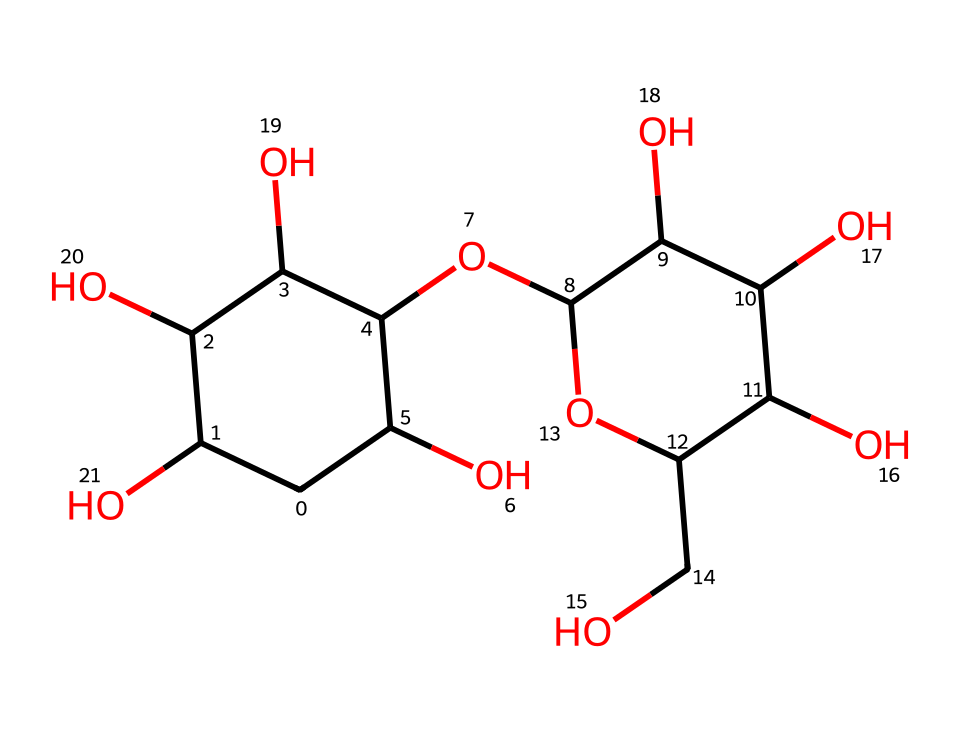What is the base sugar unit in this structure? The chemical structure shows a series of interconnected rings with hydroxyl groups, indicative of polysaccharides. The presence of multiple -OH groups confirms it is composed of sugar units, specifically glucose, which is the base unit of starch.
Answer: glucose How many hydroxyl functional groups are present? By analyzing the structure, we count the -OH groups present. Each -OH count correlates with the branched structure of cornstarch, leading to a total of six hydroxyl groups.
Answer: six What type of fluid is created by cornstarch when mixed with water? The combination of cornstarch and water results in a non-Newtonian fluid known as oobleck, where the mixture exhibits properties of both solid and liquid under different stress conditions.
Answer: non-Newtonian How does the structure affect the viscosity of oobleck? The complex starch structure leads to increased molecular interactions through hydrogen bonding among hydroxyl groups, causing the mixture to become more viscous when under stress. Therefore, it behaves differently than typical fluids.
Answer: increased viscosity What is the primary factor in oobleck’s solid-like behavior under stress? The starch’s structural integrity and the ability to form temporary bonds under stress create resistance to flow, resulting in solid-like characteristics. Key to this behavior are the associative interactions among the starch molecules.
Answer: associative interactions Which property of cornstarch causes it to act as a shear-thickening fluid? The cationic interactions and cross-linking of the starch molecules when force is applied lead to a sudden increase in viscosity, a hallmark of shear-thickening fluids like oobleck.
Answer: shear-thickening 